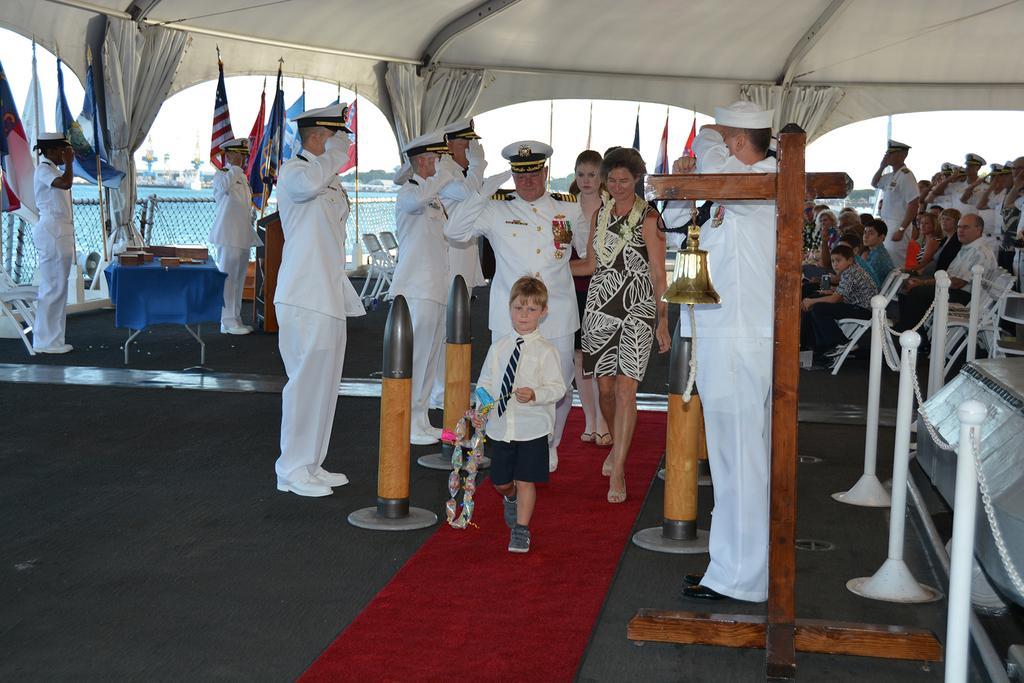How would you summarize this image in a sentence or two? In this image I can see people standing in a ship, they are shouting and wearing white uniform. 2 people are walking on the red carpet. There is a fence on the right. Few people are sitting at the back. There is a fence, curtains and flags at the back. There is water at the back. 